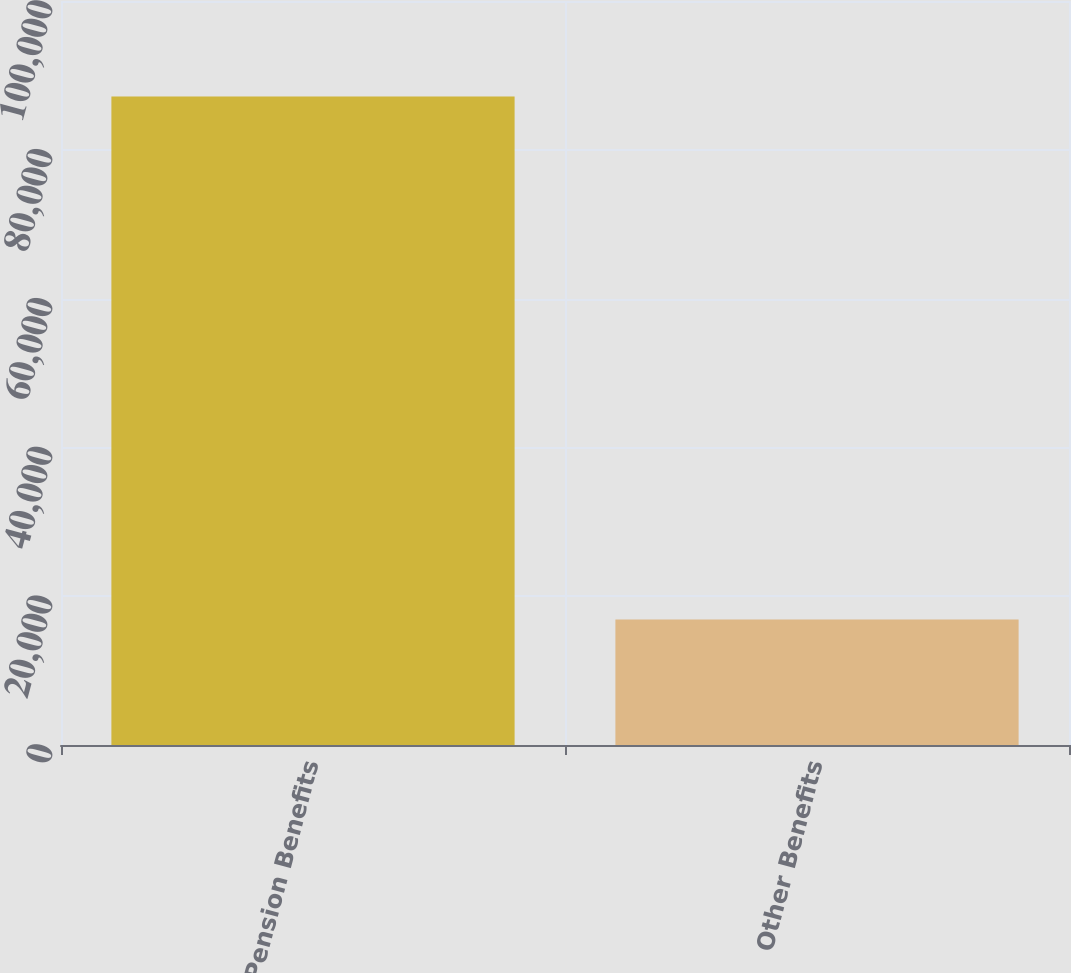Convert chart. <chart><loc_0><loc_0><loc_500><loc_500><bar_chart><fcel>Pension Benefits<fcel>Other Benefits<nl><fcel>87159<fcel>16863<nl></chart> 